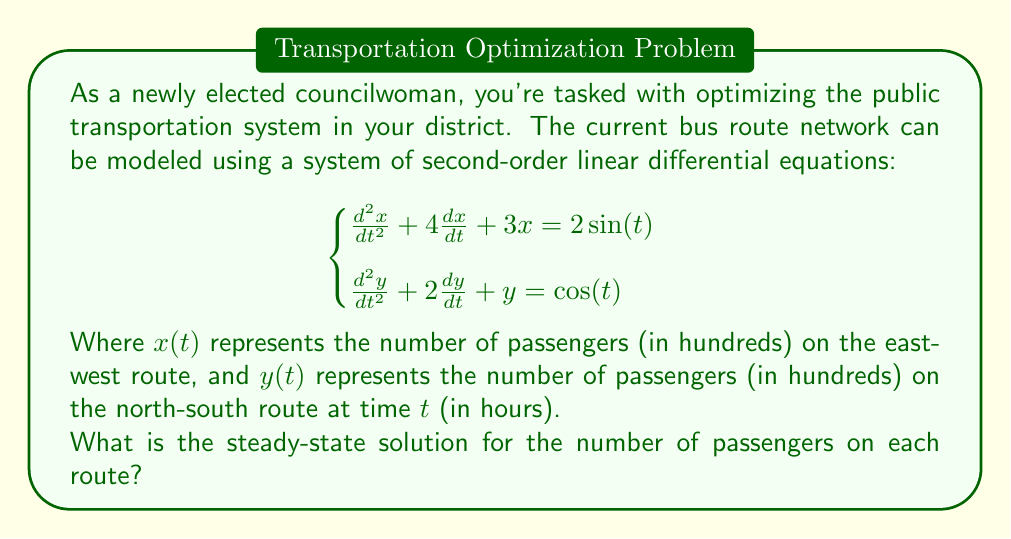Teach me how to tackle this problem. To find the steady-state solution, we need to solve for the particular solution of the system of differential equations. The general approach is as follows:

1) For a second-order linear differential equation of the form:
   $$a\frac{d^2u}{dt^2} + b\frac{du}{dt} + cu = f(t)$$
   where $f(t)$ is a sinusoidal function, the particular solution has the form:
   $$u_p(t) = A\cos(t) + B\sin(t)$$

2) For the first equation:
   $$\frac{d^2x}{dt^2} + 4\frac{dx}{dt} + 3x = 2\sin(t)$$
   Let $x_p(t) = A\cos(t) + B\sin(t)$
   
   Substituting this into the equation:
   $$(-A\cos(t) - B\sin(t)) + 4(-A\sin(t) + B\cos(t)) + 3(A\cos(t) + B\sin(t)) = 2\sin(t)$$
   
   Equating coefficients:
   $$(2A + 4B)\cos(t) + (-A + 4A + 3B)\sin(t) = 2\sin(t)$$
   
   This gives us:
   $$\begin{cases}
   2A + 4B = 0 \\
   3A + 3B = 2
   \end{cases}$$
   
   Solving this system:
   $$A = \frac{2}{5}, B = -\frac{1}{5}$$

   Therefore, $x_p(t) = \frac{2}{5}\cos(t) - \frac{1}{5}\sin(t)$

3) For the second equation:
   $$\frac{d^2y}{dt^2} + 2\frac{dy}{dt} + y = \cos(t)$$
   Let $y_p(t) = C\cos(t) + D\sin(t)$
   
   Following the same process:
   $$(-C\cos(t) - D\sin(t)) + 2(-C\sin(t) + D\cos(t)) + (C\cos(t) + D\sin(t)) = \cos(t)$$
   
   Equating coefficients:
   $$(2D)\cos(t) + (-C - 2C + D)\sin(t) = \cos(t)$$
   
   This gives us:
   $$\begin{cases}
   2D = 1 \\
   -3C + D = 0
   \end{cases}$$
   
   Solving this system:
   $$C = \frac{1}{6}, D = \frac{1}{2}$$

   Therefore, $y_p(t) = \frac{1}{6}\cos(t) + \frac{1}{2}\sin(t)$

The steady-state solution is given by these particular solutions.
Answer: The steady-state solution is:
$$\begin{cases}
x(t) = \frac{2}{5}\cos(t) - \frac{1}{5}\sin(t) \\
y(t) = \frac{1}{6}\cos(t) + \frac{1}{2}\sin(t)
\end{cases}$$ 